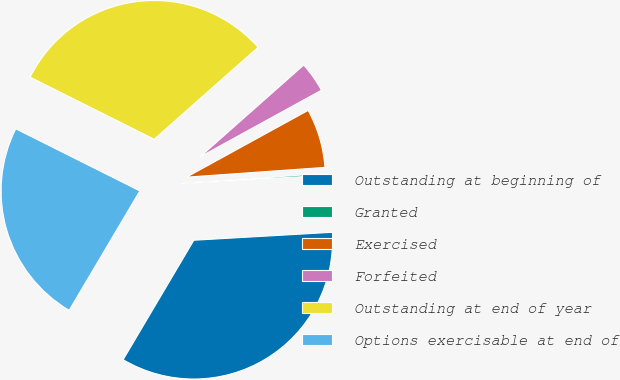<chart> <loc_0><loc_0><loc_500><loc_500><pie_chart><fcel>Outstanding at beginning of<fcel>Granted<fcel>Exercised<fcel>Forfeited<fcel>Outstanding at end of year<fcel>Options exercisable at end of<nl><fcel>34.42%<fcel>0.21%<fcel>6.87%<fcel>3.54%<fcel>31.08%<fcel>23.88%<nl></chart> 